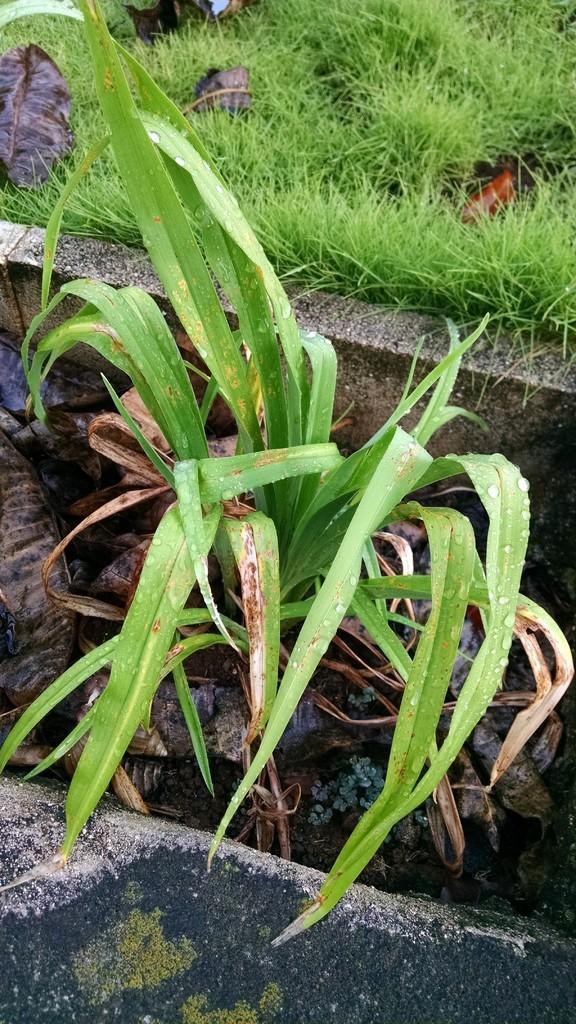In one or two sentences, can you explain what this image depicts? In this image there are plants, grass and there are dry leaves. 